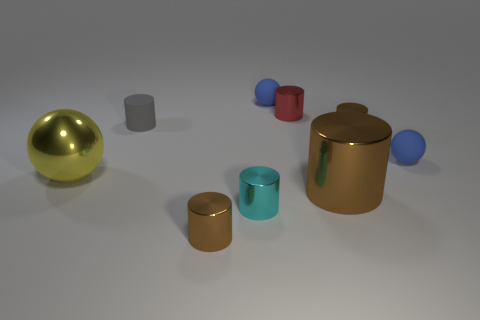Subtract all yellow shiny balls. How many balls are left? 2 Add 1 tiny yellow metal cylinders. How many objects exist? 10 Subtract all blue balls. How many balls are left? 1 Subtract all spheres. How many objects are left? 6 Subtract 1 cylinders. How many cylinders are left? 5 Subtract all blue spheres. Subtract all matte balls. How many objects are left? 5 Add 1 small matte spheres. How many small matte spheres are left? 3 Add 7 cyan objects. How many cyan objects exist? 8 Subtract 0 green blocks. How many objects are left? 9 Subtract all red cylinders. Subtract all cyan spheres. How many cylinders are left? 5 